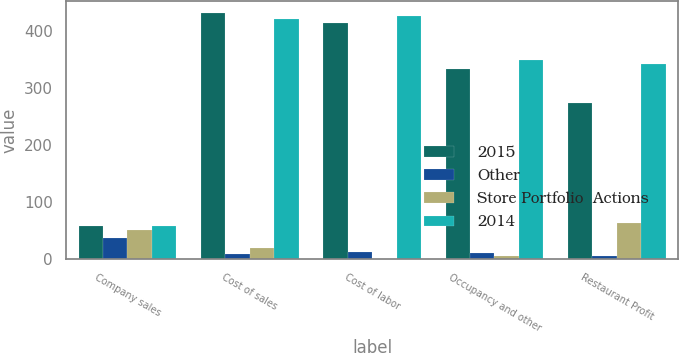Convert chart. <chart><loc_0><loc_0><loc_500><loc_500><stacked_bar_chart><ecel><fcel>Company sales<fcel>Cost of sales<fcel>Cost of labor<fcel>Occupancy and other<fcel>Restaurant Profit<nl><fcel>2015<fcel>57.5<fcel>431<fcel>414<fcel>333<fcel>274<nl><fcel>Other<fcel>38<fcel>10<fcel>12<fcel>11<fcel>5<nl><fcel>Store Portfolio  Actions<fcel>51<fcel>20<fcel>1<fcel>6<fcel>64<nl><fcel>2014<fcel>57.5<fcel>421<fcel>427<fcel>350<fcel>343<nl></chart> 